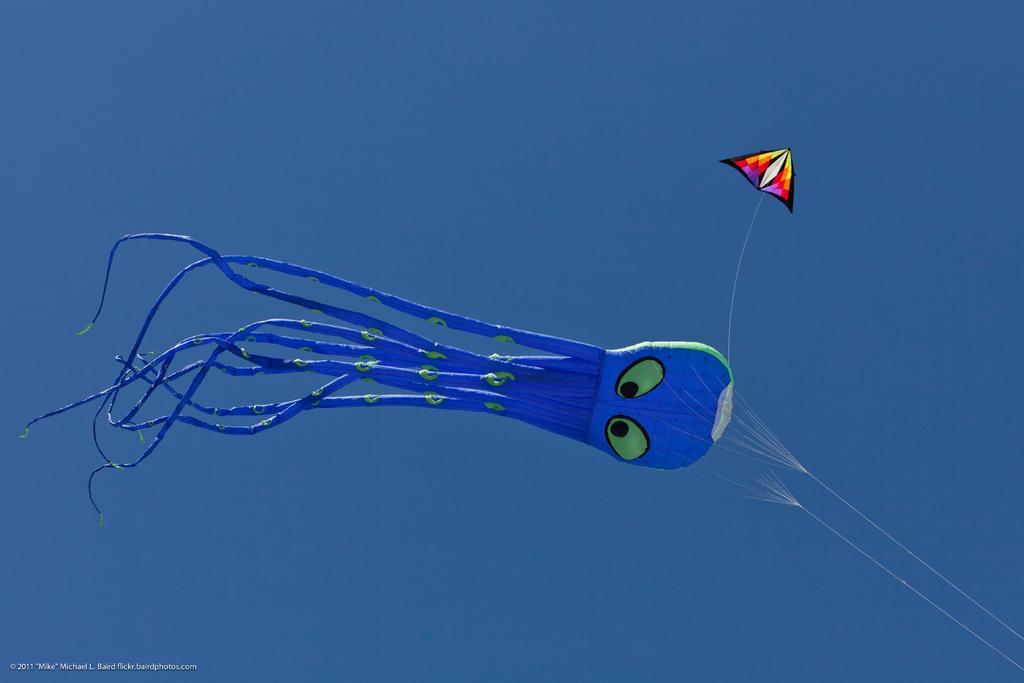Please provide a concise description of this image. In the image there is an air filled balloon and a kite are flying in the air. 